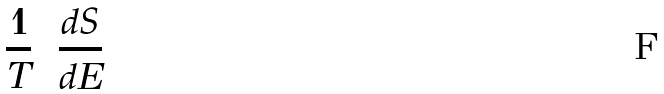<formula> <loc_0><loc_0><loc_500><loc_500>\frac { 1 } { T } = \frac { d S } { d E }</formula> 